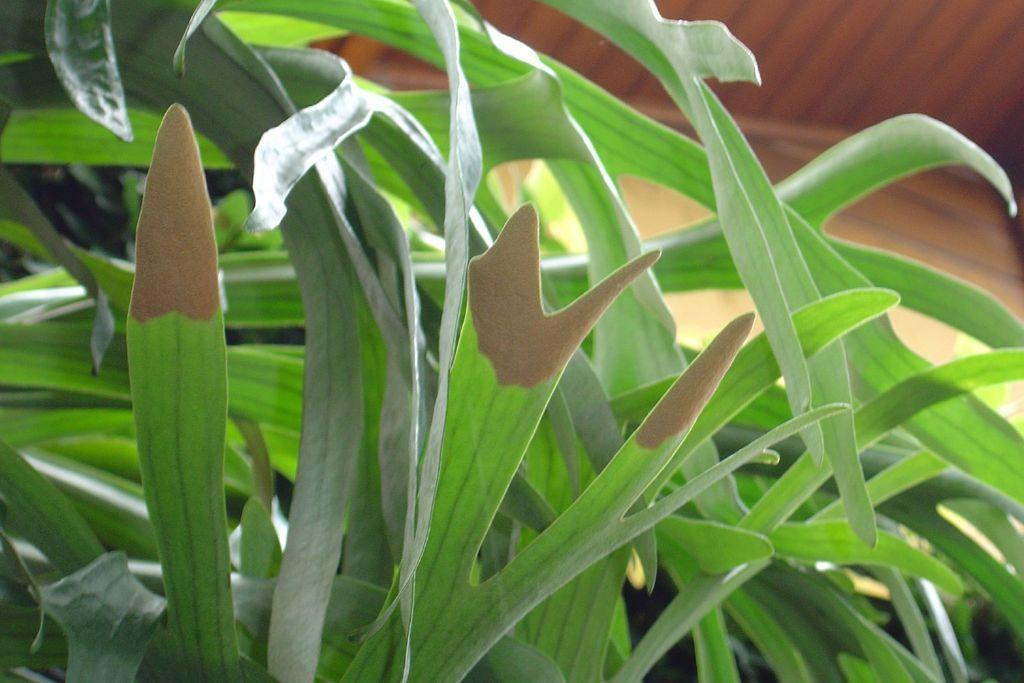What type of living organism is in the image? There is a plant in the image. Can you describe the appearance of the plant's leaves? The plant has long leaves. What material is the wall behind the plant made of? There is a wooden wall behind the plant. How many chickens are sitting on the van in the image? There are no chickens or vans present in the image. 